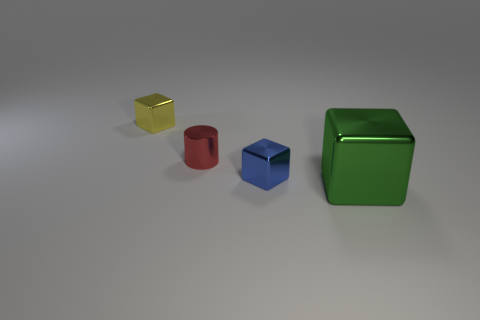Does the shiny cylinder have the same color as the tiny cube that is on the right side of the small yellow metal object?
Ensure brevity in your answer.  No. Is the number of small blue objects that are behind the tiny yellow cube less than the number of yellow metal blocks on the right side of the small red cylinder?
Ensure brevity in your answer.  No. What is the color of the block that is left of the green cube and on the right side of the tiny yellow cube?
Make the answer very short. Blue. There is a blue metal block; does it have the same size as the green shiny thing right of the small cylinder?
Keep it short and to the point. No. The tiny thing left of the small red metallic cylinder has what shape?
Your response must be concise. Cube. Are there any other things that have the same material as the large green cube?
Provide a short and direct response. Yes. Is the number of green shiny things that are to the right of the small shiny cylinder greater than the number of tiny metal things?
Your response must be concise. No. There is a block that is behind the tiny blue metallic thing in front of the red thing; what number of small blue metal cubes are left of it?
Provide a short and direct response. 0. Is the size of the thing that is in front of the tiny blue thing the same as the object that is behind the red metal thing?
Offer a terse response. No. There is a green object that is in front of the tiny metallic cube in front of the small yellow metallic thing; what is its material?
Offer a terse response. Metal. 